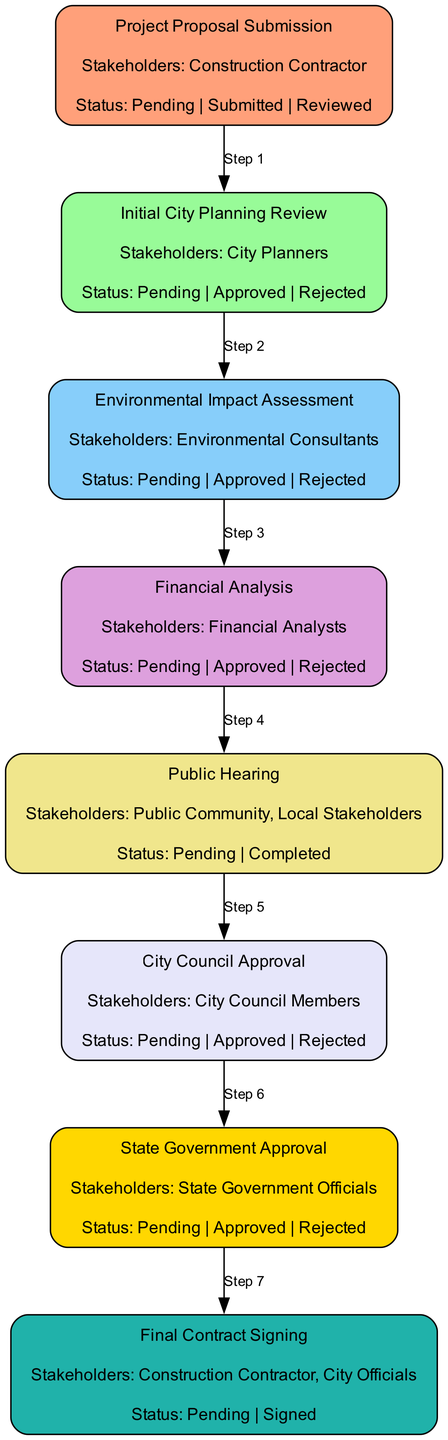What is the first step in the approval process? The first step shown in the diagram is "Project Proposal Submission". It is the starting point where the construction contractor submits their initial proposal.
Answer: Project Proposal Submission How many total stages are involved in the stakeholder approval process? By counting the blocks in the diagram, there are 8 distinct stages indicated in the process.
Answer: 8 Which stakeholder is involved in the "Environmental Impact Assessment"? The diagram specifies that "Environmental Consultants" are the stakeholders involved in this particular stage of the approval process.
Answer: Environmental Consultants What is the status option available after the "Public Hearing"? In the diagram, the status options available after the "Public Hearing" stage are "Pending" and "Completed", indicating the closure of community feedback.
Answer: Pending, Completed Which step follows "Initial City Planning Review"? The flow in the diagram shows that the "Environmental Impact Assessment" directly follows the "Initial City Planning Review". This indicates a sequential progression of stages.
Answer: Environmental Impact Assessment What is the last step in the approval process? The final step illustrated in the diagram is "Final Contract Signing". This stage signifies the official signing of the contract between the construction contractor and city officials.
Answer: Final Contract Signing Which two stakeholder groups are shown in the "City Council Approval"? According to the diagram, the stakeholders involved in the "City Council Approval" stage are exclusively "City Council Members".
Answer: City Council Members How does "Financial Analysis" relate to "City Council Approval"? In the approval process, the "Financial Analysis" is assessed before the "City Council Approval", indicating that the analysis is a prerequisite for council review.
Answer: Prerequisite What is the status of the "Final Contract Signing" when it is signed? The status option available when the "Final Contract Signing" is completed is "Signed", marking the completion of this crucial stage.
Answer: Signed 